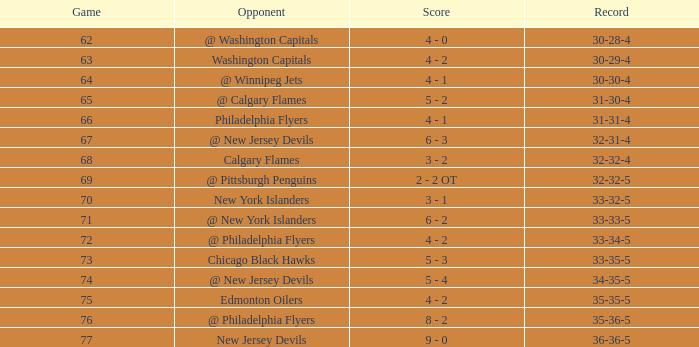How many games ended in a record of 30-28-4, with a March more than 1? 0.0. 